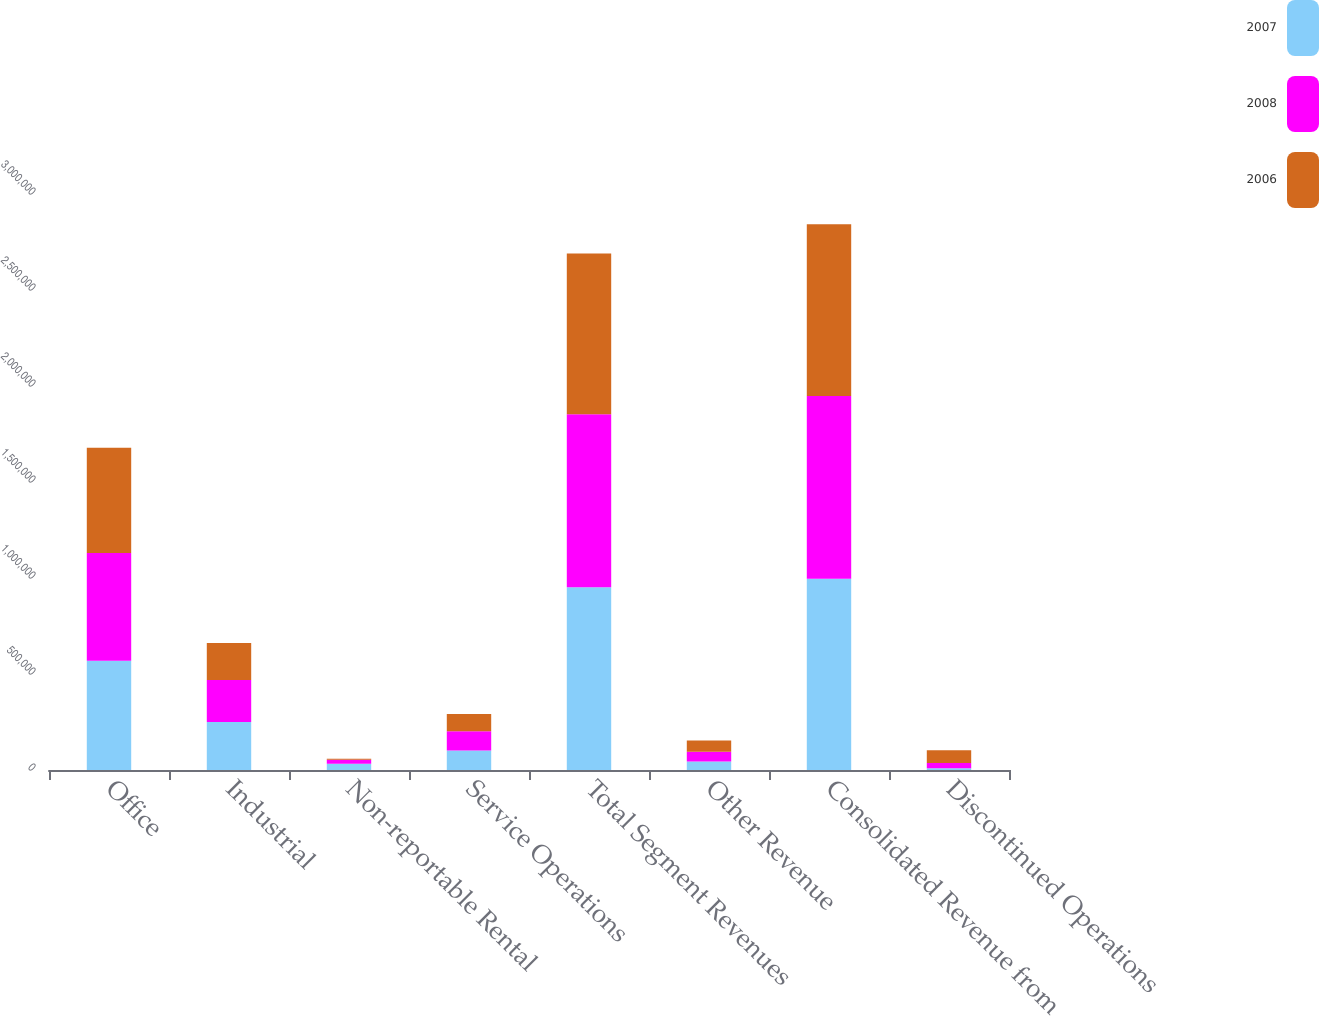<chart> <loc_0><loc_0><loc_500><loc_500><stacked_bar_chart><ecel><fcel>Office<fcel>Industrial<fcel>Non-reportable Rental<fcel>Service Operations<fcel>Total Segment Revenues<fcel>Other Revenue<fcel>Consolidated Revenue from<fcel>Discontinued Operations<nl><fcel>2007<fcel>568405<fcel>250078<fcel>31987<fcel>101898<fcel>952368<fcel>43719<fcel>996087<fcel>9012<nl><fcel>2008<fcel>562277<fcel>218055<fcel>20952<fcel>99358<fcel>900642<fcel>50805<fcel>951447<fcel>27343<nl><fcel>2006<fcel>547370<fcel>193675<fcel>5775<fcel>90125<fcel>836945<fcel>58476<fcel>895421<fcel>65969<nl></chart> 